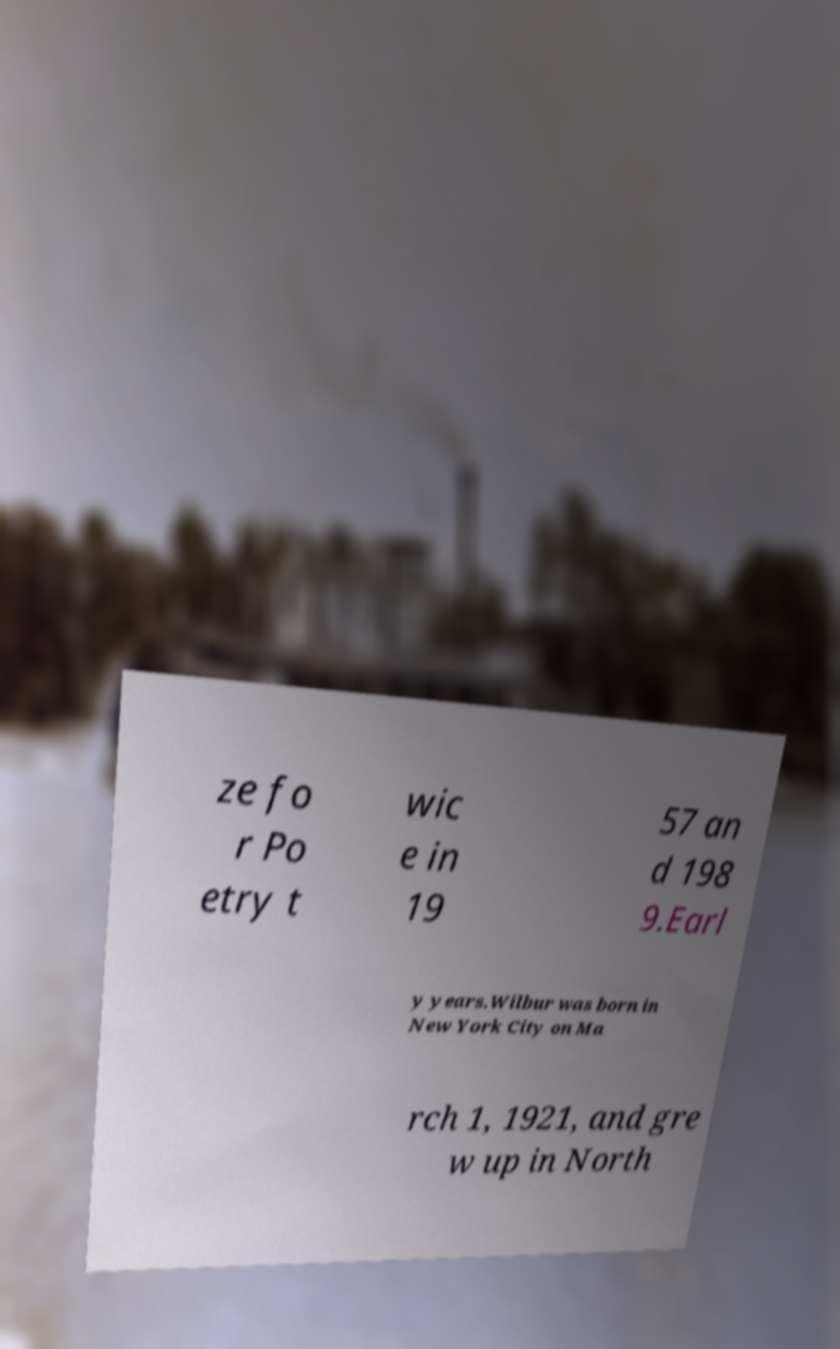Can you read and provide the text displayed in the image?This photo seems to have some interesting text. Can you extract and type it out for me? ze fo r Po etry t wic e in 19 57 an d 198 9.Earl y years.Wilbur was born in New York City on Ma rch 1, 1921, and gre w up in North 